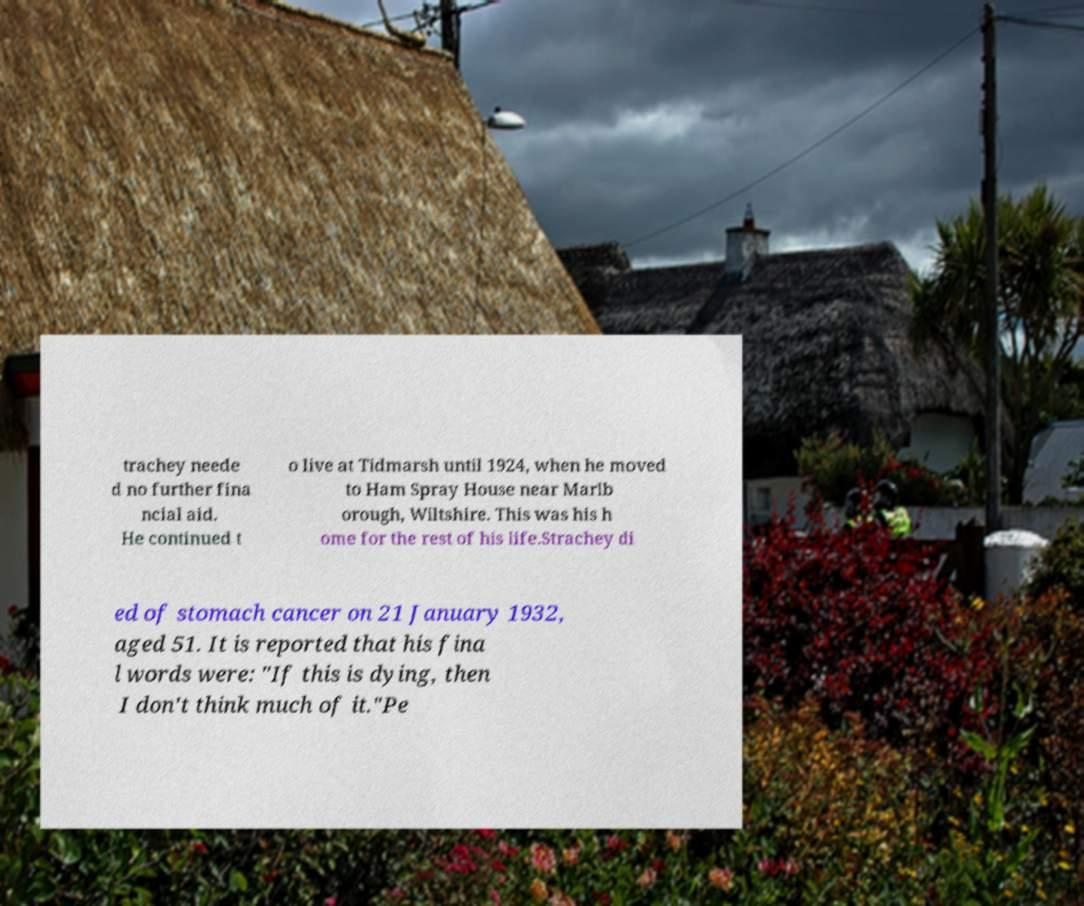Can you accurately transcribe the text from the provided image for me? trachey neede d no further fina ncial aid. He continued t o live at Tidmarsh until 1924, when he moved to Ham Spray House near Marlb orough, Wiltshire. This was his h ome for the rest of his life.Strachey di ed of stomach cancer on 21 January 1932, aged 51. It is reported that his fina l words were: "If this is dying, then I don't think much of it."Pe 